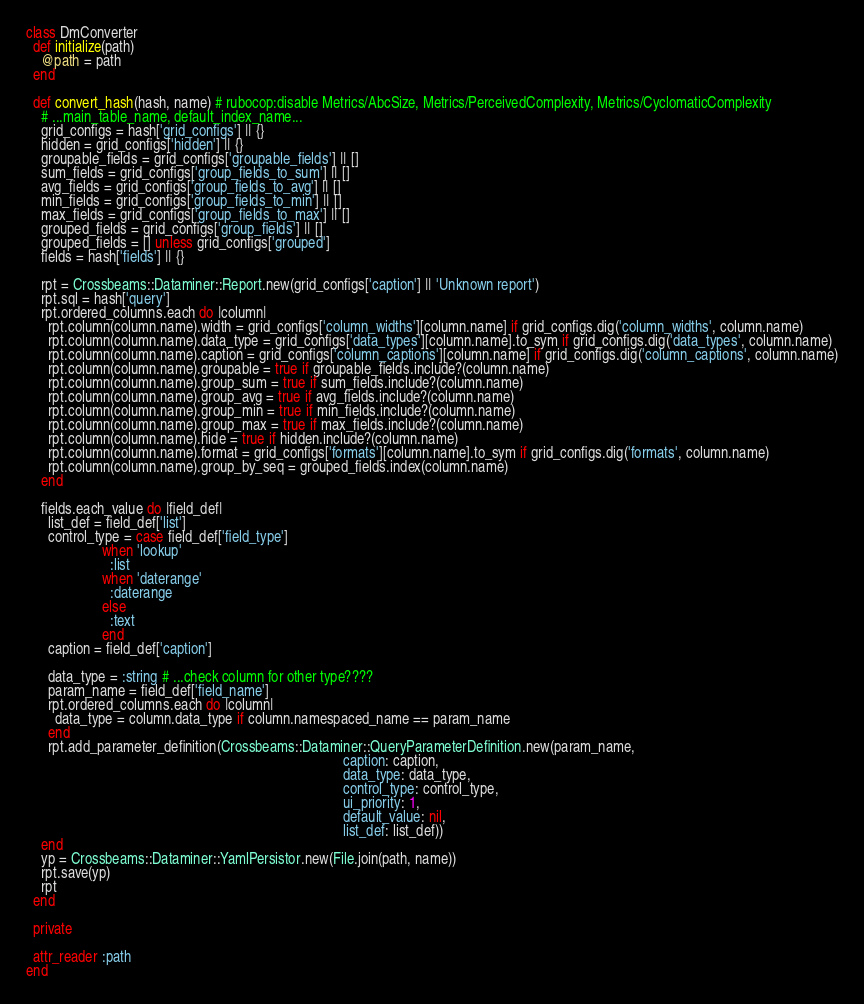Convert code to text. <code><loc_0><loc_0><loc_500><loc_500><_Ruby_>class DmConverter
  def initialize(path)
    @path = path
  end

  def convert_hash(hash, name) # rubocop:disable Metrics/AbcSize, Metrics/PerceivedComplexity, Metrics/CyclomaticComplexity
    # ...main_table_name, default_index_name...
    grid_configs = hash['grid_configs'] || {}
    hidden = grid_configs['hidden'] || {}
    groupable_fields = grid_configs['groupable_fields'] || []
    sum_fields = grid_configs['group_fields_to_sum'] || []
    avg_fields = grid_configs['group_fields_to_avg'] || []
    min_fields = grid_configs['group_fields_to_min'] || []
    max_fields = grid_configs['group_fields_to_max'] || []
    grouped_fields = grid_configs['group_fields'] || []
    grouped_fields = [] unless grid_configs['grouped']
    fields = hash['fields'] || {}

    rpt = Crossbeams::Dataminer::Report.new(grid_configs['caption'] || 'Unknown report')
    rpt.sql = hash['query']
    rpt.ordered_columns.each do |column|
      rpt.column(column.name).width = grid_configs['column_widths'][column.name] if grid_configs.dig('column_widths', column.name)
      rpt.column(column.name).data_type = grid_configs['data_types'][column.name].to_sym if grid_configs.dig('data_types', column.name)
      rpt.column(column.name).caption = grid_configs['column_captions'][column.name] if grid_configs.dig('column_captions', column.name)
      rpt.column(column.name).groupable = true if groupable_fields.include?(column.name)
      rpt.column(column.name).group_sum = true if sum_fields.include?(column.name)
      rpt.column(column.name).group_avg = true if avg_fields.include?(column.name)
      rpt.column(column.name).group_min = true if min_fields.include?(column.name)
      rpt.column(column.name).group_max = true if max_fields.include?(column.name)
      rpt.column(column.name).hide = true if hidden.include?(column.name)
      rpt.column(column.name).format = grid_configs['formats'][column.name].to_sym if grid_configs.dig('formats', column.name)
      rpt.column(column.name).group_by_seq = grouped_fields.index(column.name)
    end

    fields.each_value do |field_def|
      list_def = field_def['list']
      control_type = case field_def['field_type']
                     when 'lookup'
                       :list
                     when 'daterange'
                       :daterange
                     else
                       :text
                     end
      caption = field_def['caption']

      data_type = :string # ...check column for other type????
      param_name = field_def['field_name']
      rpt.ordered_columns.each do |column|
        data_type = column.data_type if column.namespaced_name == param_name
      end
      rpt.add_parameter_definition(Crossbeams::Dataminer::QueryParameterDefinition.new(param_name,
                                                                                       caption: caption,
                                                                                       data_type: data_type,
                                                                                       control_type: control_type,
                                                                                       ui_priority: 1,
                                                                                       default_value: nil,
                                                                                       list_def: list_def))
    end
    yp = Crossbeams::Dataminer::YamlPersistor.new(File.join(path, name))
    rpt.save(yp)
    rpt
  end

  private

  attr_reader :path
end
</code> 